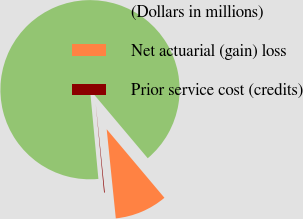<chart> <loc_0><loc_0><loc_500><loc_500><pie_chart><fcel>(Dollars in millions)<fcel>Net actuarial (gain) loss<fcel>Prior service cost (credits)<nl><fcel>90.34%<fcel>9.52%<fcel>0.13%<nl></chart> 